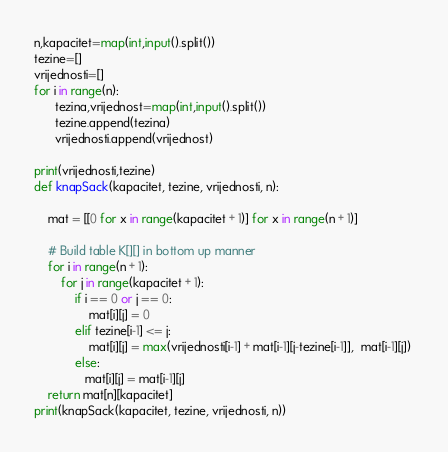<code> <loc_0><loc_0><loc_500><loc_500><_Python_>n,kapacitet=map(int,input().split())
tezine=[]
vrijednosti=[]
for i in range(n):
      tezina,vrijednost=map(int,input().split())
      tezine.append(tezina)
      vrijednosti.append(vrijednost)

print(vrijednosti,tezine)
def knapSack(kapacitet, tezine, vrijednosti, n):

    mat = [[0 for x in range(kapacitet + 1)] for x in range(n + 1)] 
  
    # Build table K[][] in bottom up manner 
    for i in range(n + 1): 
        for j in range(kapacitet + 1): 
            if i == 0 or j == 0: 
                mat[i][j] = 0
            elif tezine[i-1] <= j: 
                mat[i][j] = max(vrijednosti[i-1] + mat[i-1][j-tezine[i-1]],  mat[i-1][j]) 
            else: 
               mat[i][j] = mat[i-1][j]   
    return mat[n][kapacitet]
print(knapSack(kapacitet, tezine, vrijednosti, n)) </code> 